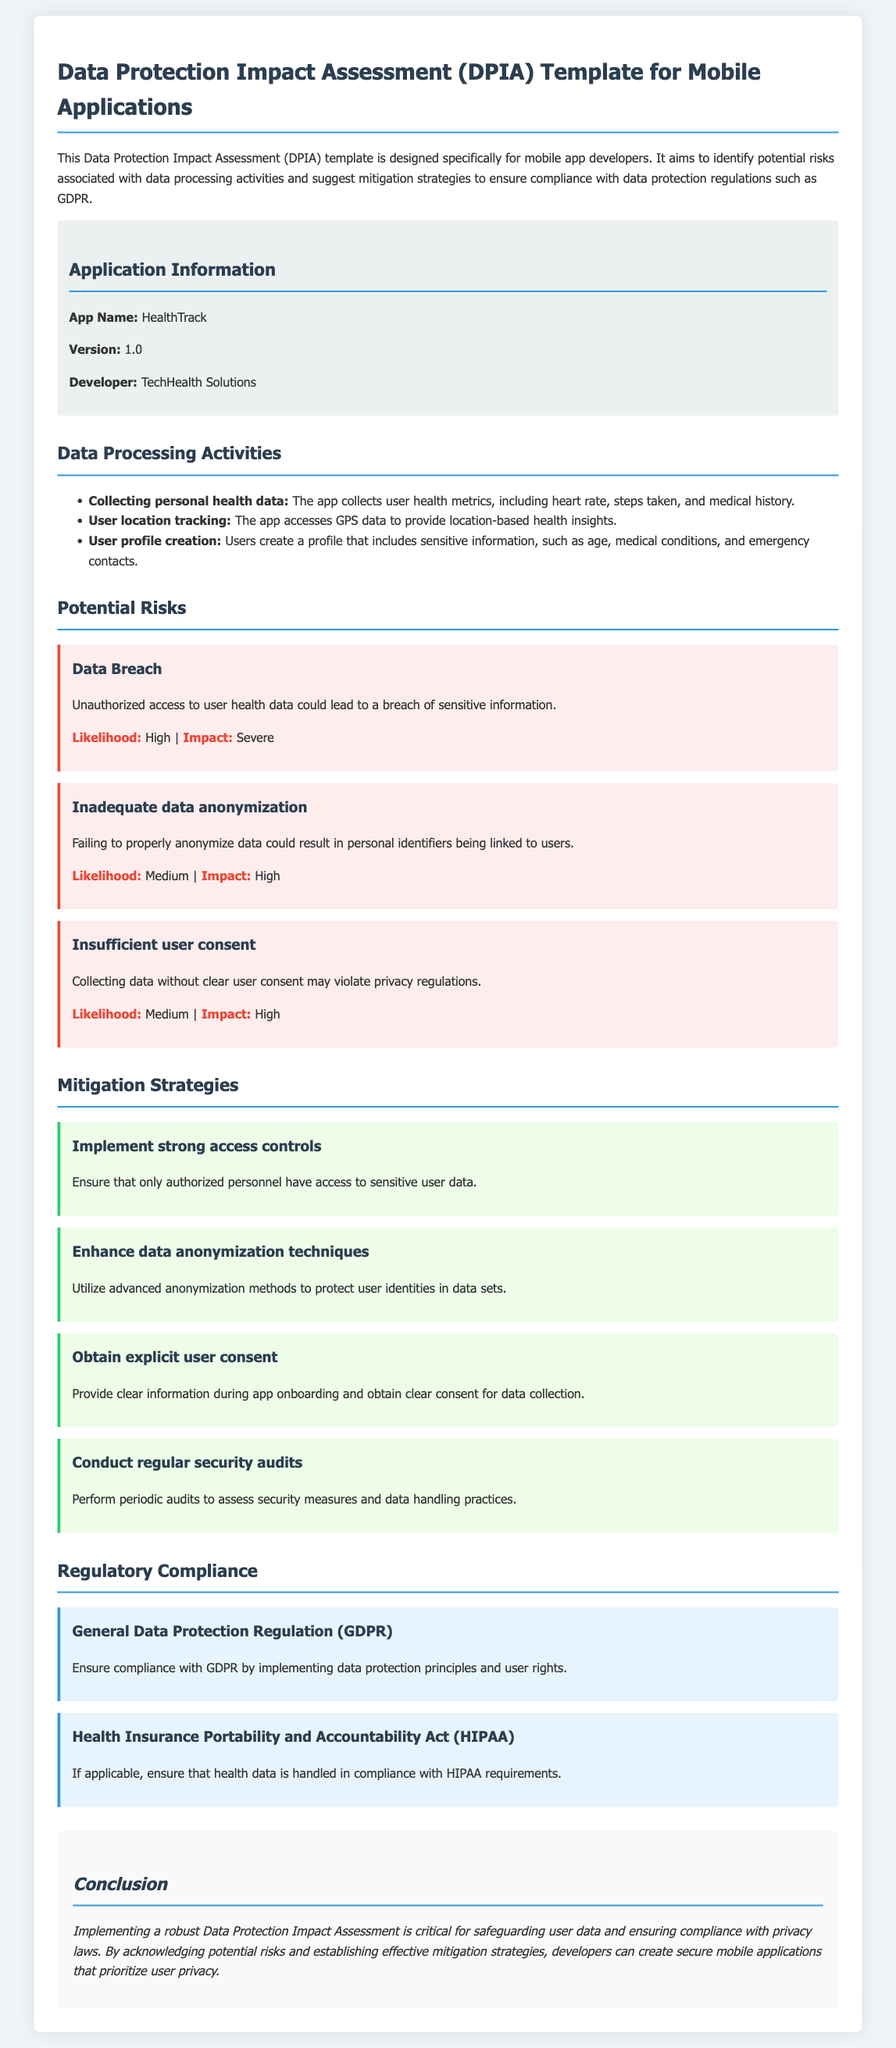What is the app name? The app name is provided in the Application Information section.
Answer: HealthTrack What is the developer's name? The developer's name is listed in the Application Information section.
Answer: TechHealth Solutions What is a potential risk related to unauthorized access? This risk is categorized in the Potential Risks section.
Answer: Data Breach What is the likelihood of inadequate data anonymization? The likelihood of this risk is mentioned in the Potential Risks section.
Answer: Medium What mitigation strategy focuses on user approval? This strategy can be found under Mitigation Strategies.
Answer: Obtain explicit user consent Which regulation is specifically mentioned for compliance? This regulation is highlighted in the Regulatory Compliance section.
Answer: General Data Protection Regulation (GDPR) How many data processing activities are outlined? The number of activities is stated in the Data Processing Activities section.
Answer: Three What is the impact rating for insufficient user consent? The impact rating is provided in the Potential Risks section for this risk.
Answer: High What type of audits should be conducted regularly? This is detailed in the Mitigation Strategies section.
Answer: Security audits 